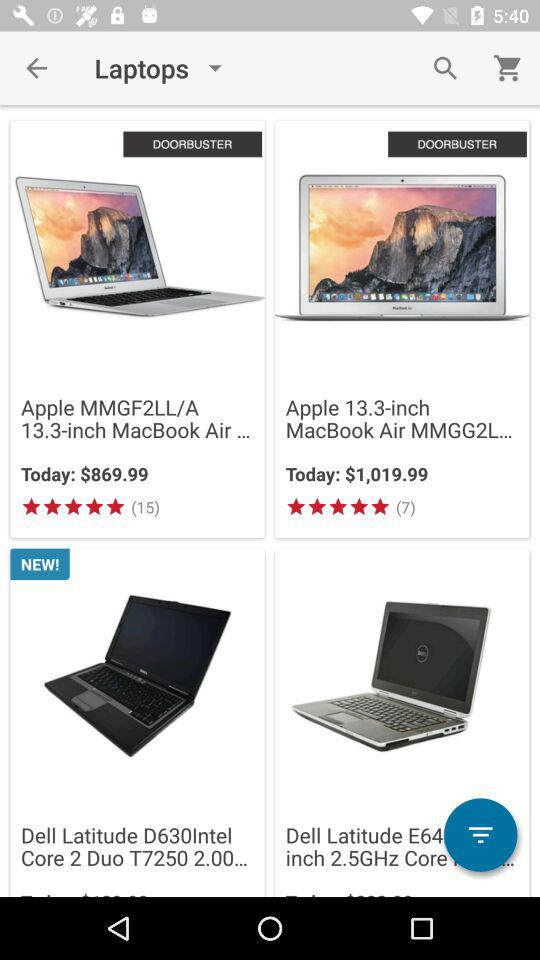Which laptop costs $869.99? The laptop that costs $869.99 is the "Apple MMGF2LL/A 13.3-inch MacBook Air...". 